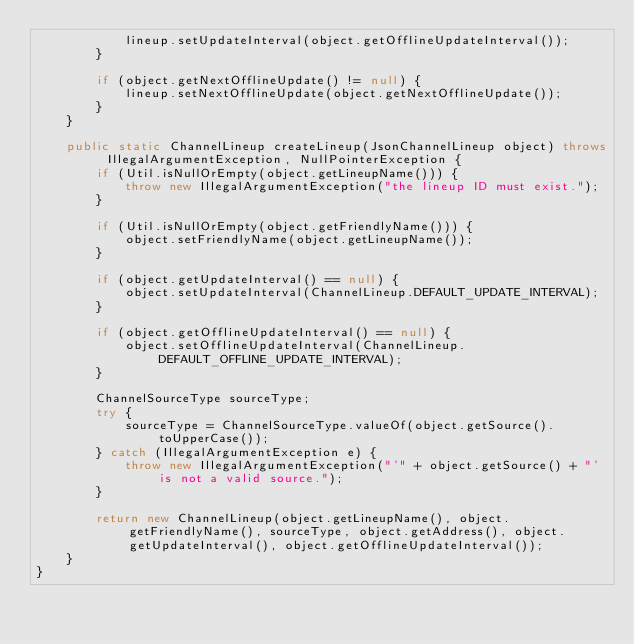<code> <loc_0><loc_0><loc_500><loc_500><_Java_>            lineup.setUpdateInterval(object.getOfflineUpdateInterval());
        }

        if (object.getNextOfflineUpdate() != null) {
            lineup.setNextOfflineUpdate(object.getNextOfflineUpdate());
        }
    }

    public static ChannelLineup createLineup(JsonChannelLineup object) throws IllegalArgumentException, NullPointerException {
        if (Util.isNullOrEmpty(object.getLineupName())) {
            throw new IllegalArgumentException("the lineup ID must exist.");
        }

        if (Util.isNullOrEmpty(object.getFriendlyName())) {
            object.setFriendlyName(object.getLineupName());
        }

        if (object.getUpdateInterval() == null) {
            object.setUpdateInterval(ChannelLineup.DEFAULT_UPDATE_INTERVAL);
        }

        if (object.getOfflineUpdateInterval() == null) {
            object.setOfflineUpdateInterval(ChannelLineup.DEFAULT_OFFLINE_UPDATE_INTERVAL);
        }

        ChannelSourceType sourceType;
        try {
            sourceType = ChannelSourceType.valueOf(object.getSource().toUpperCase());
        } catch (IllegalArgumentException e) {
            throw new IllegalArgumentException("'" + object.getSource() + "' is not a valid source.");
        }

        return new ChannelLineup(object.getLineupName(), object.getFriendlyName(), sourceType, object.getAddress(), object.getUpdateInterval(), object.getOfflineUpdateInterval());
    }
}
</code> 